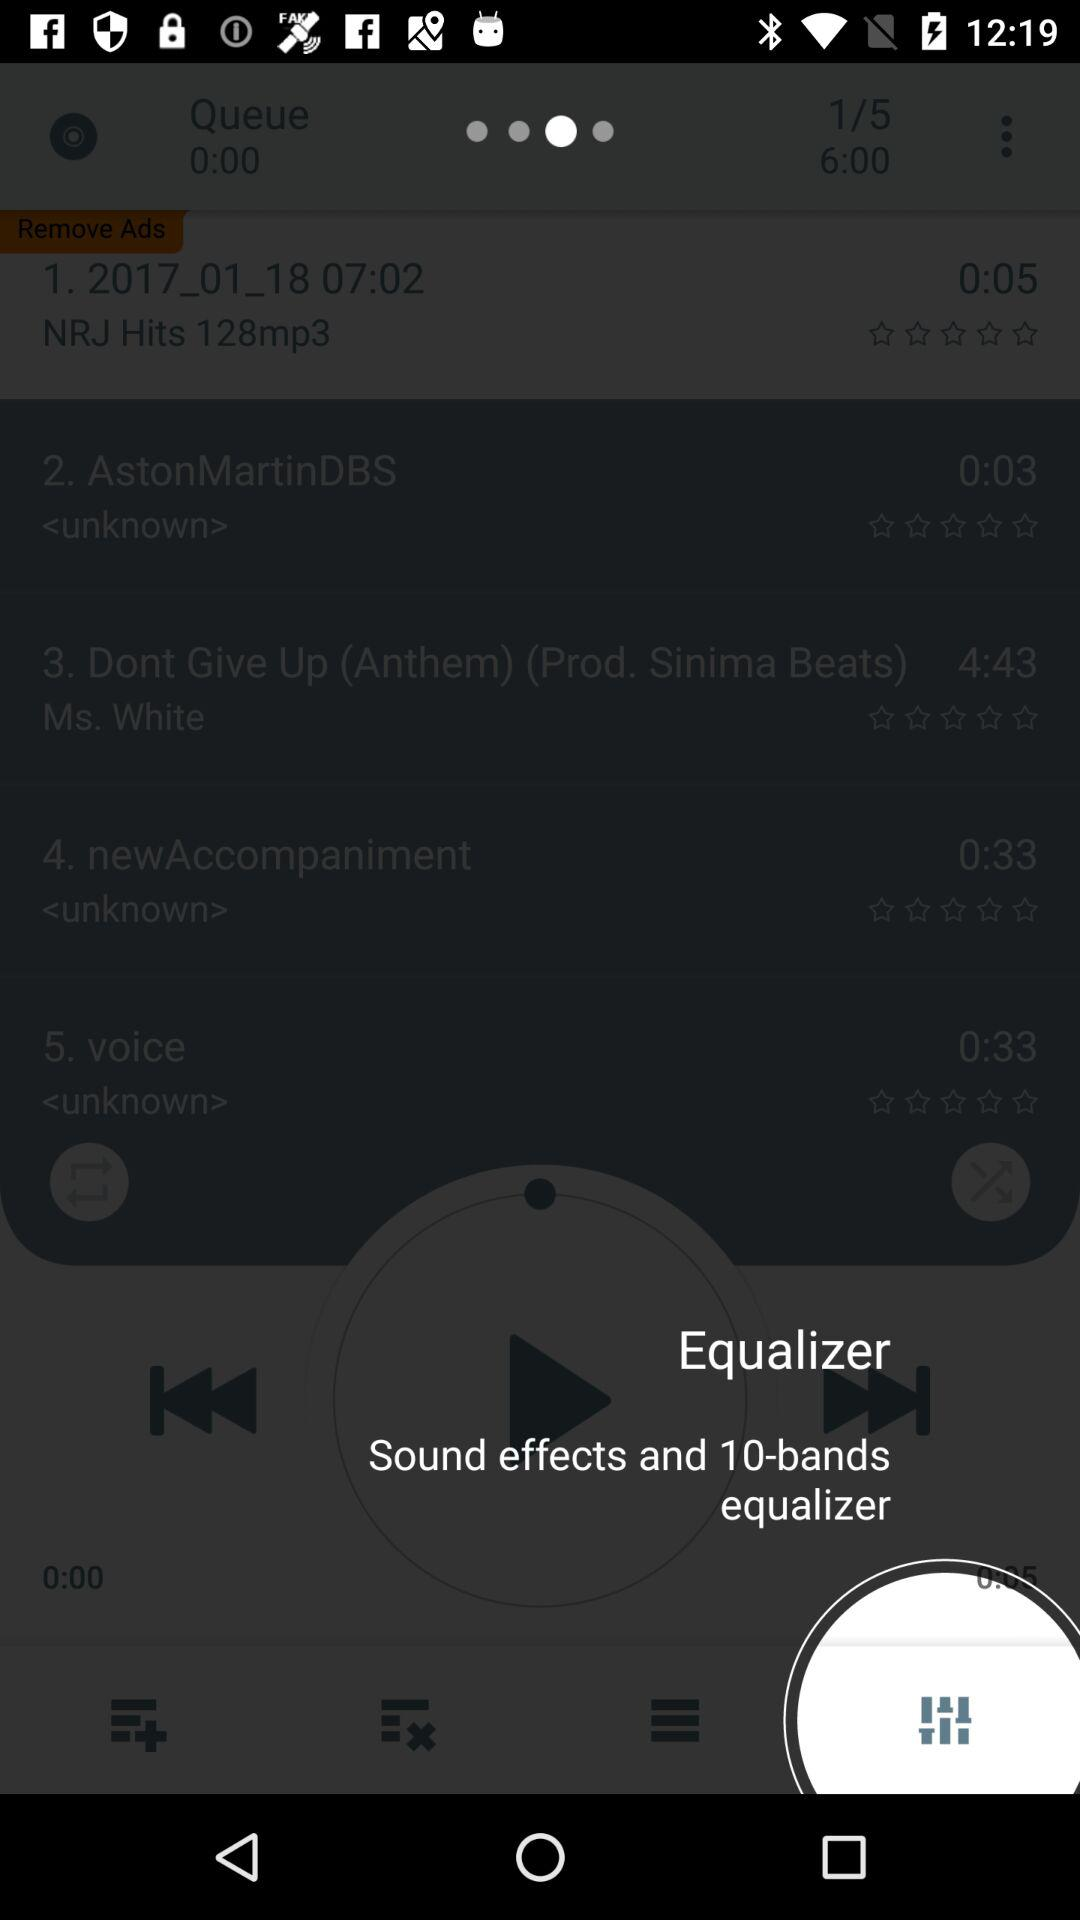How many bands does the equalizer have? The equalizer has 10 bands. 